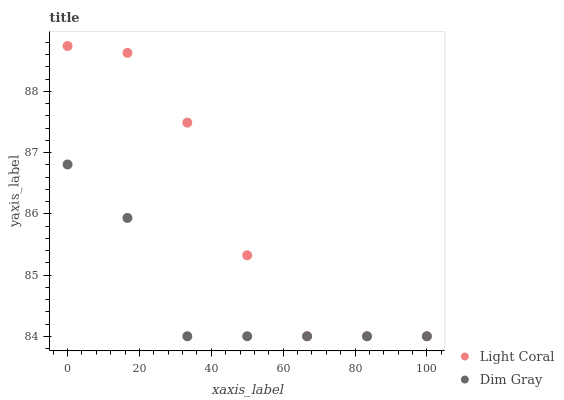Does Dim Gray have the minimum area under the curve?
Answer yes or no. Yes. Does Light Coral have the maximum area under the curve?
Answer yes or no. Yes. Does Dim Gray have the maximum area under the curve?
Answer yes or no. No. Is Dim Gray the smoothest?
Answer yes or no. Yes. Is Light Coral the roughest?
Answer yes or no. Yes. Is Dim Gray the roughest?
Answer yes or no. No. Does Light Coral have the lowest value?
Answer yes or no. Yes. Does Light Coral have the highest value?
Answer yes or no. Yes. Does Dim Gray have the highest value?
Answer yes or no. No. Does Light Coral intersect Dim Gray?
Answer yes or no. Yes. Is Light Coral less than Dim Gray?
Answer yes or no. No. Is Light Coral greater than Dim Gray?
Answer yes or no. No. 